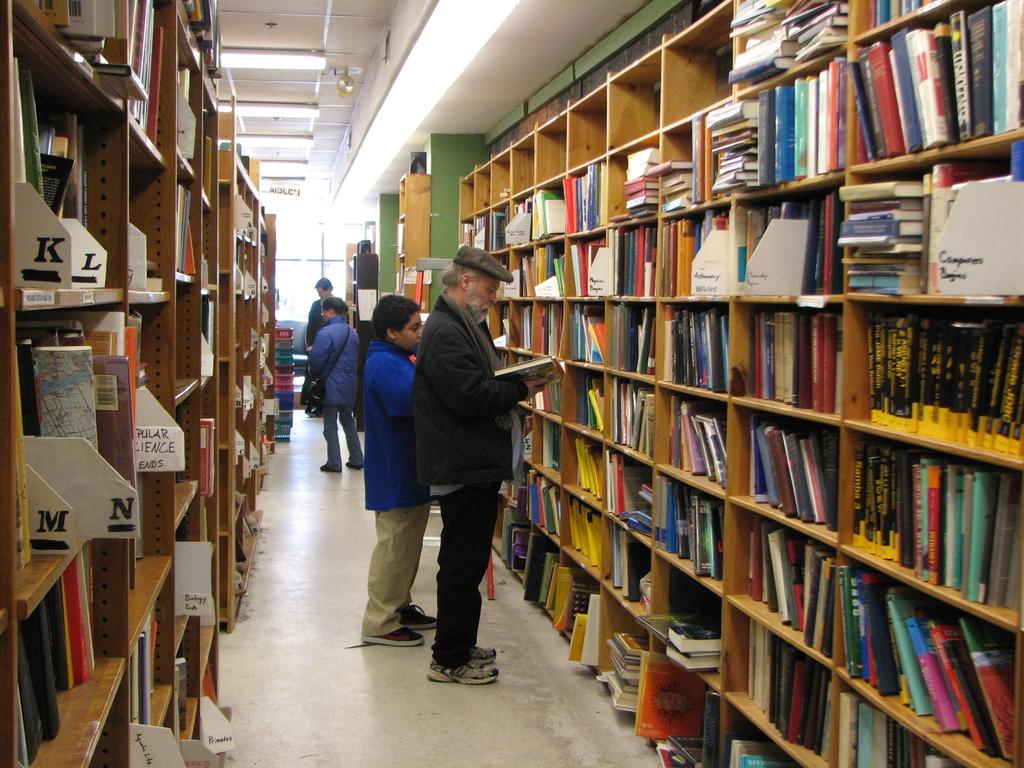What letters do you see?
Give a very brief answer. Klmn. 